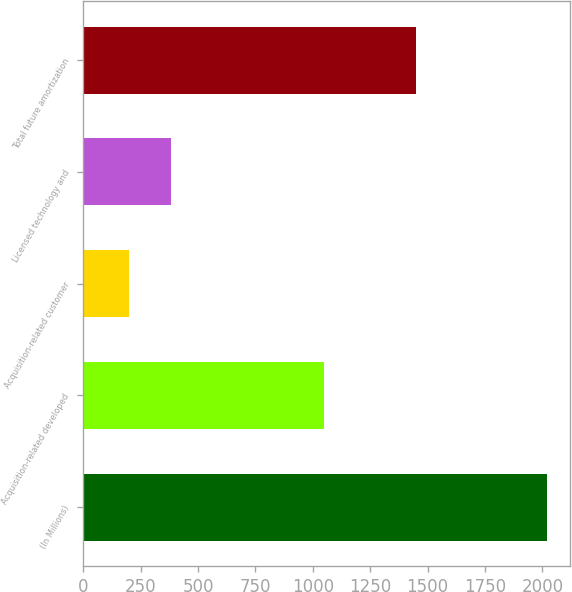Convert chart to OTSL. <chart><loc_0><loc_0><loc_500><loc_500><bar_chart><fcel>(In Millions)<fcel>Acquisition-related developed<fcel>Acquisition-related customer<fcel>Licensed technology and<fcel>Total future amortization<nl><fcel>2021<fcel>1047<fcel>199<fcel>381.2<fcel>1450<nl></chart> 